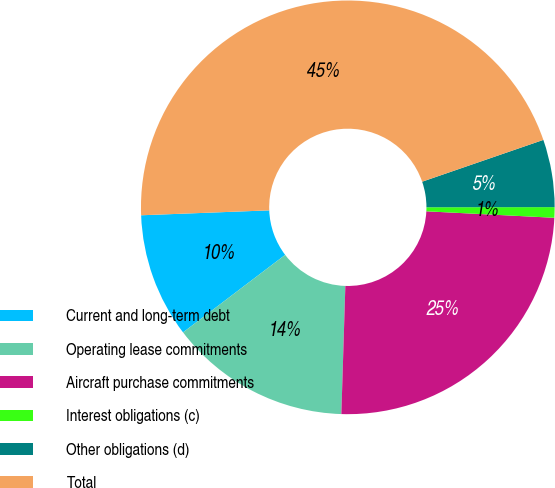Convert chart. <chart><loc_0><loc_0><loc_500><loc_500><pie_chart><fcel>Current and long-term debt<fcel>Operating lease commitments<fcel>Aircraft purchase commitments<fcel>Interest obligations (c)<fcel>Other obligations (d)<fcel>Total<nl><fcel>9.72%<fcel>14.17%<fcel>24.69%<fcel>0.82%<fcel>5.27%<fcel>45.32%<nl></chart> 